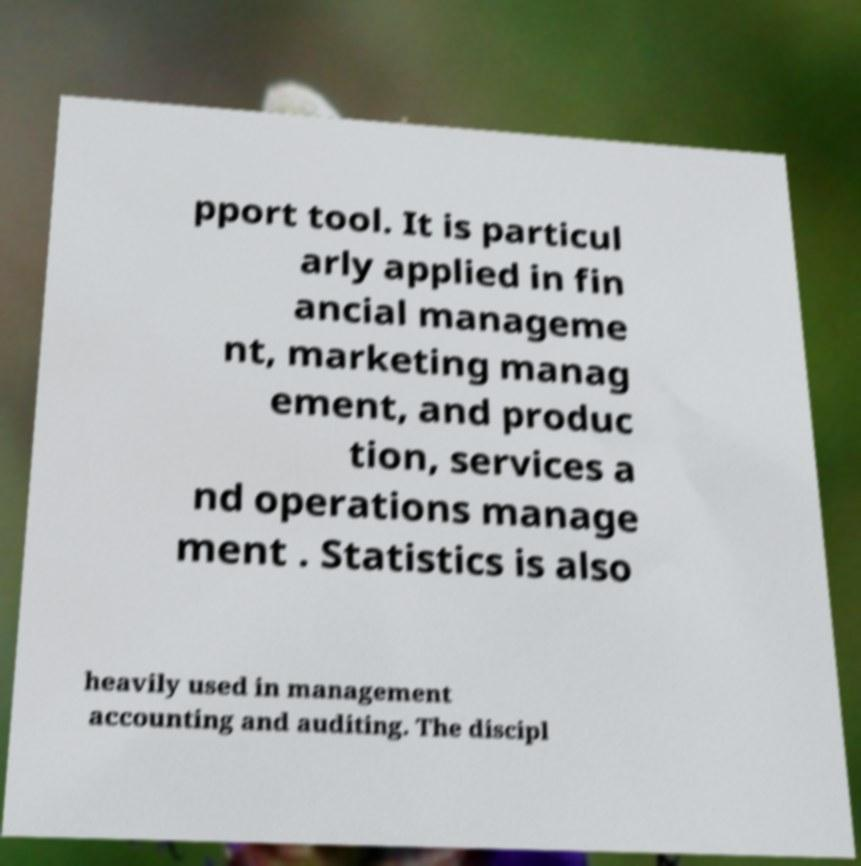There's text embedded in this image that I need extracted. Can you transcribe it verbatim? pport tool. It is particul arly applied in fin ancial manageme nt, marketing manag ement, and produc tion, services a nd operations manage ment . Statistics is also heavily used in management accounting and auditing. The discipl 